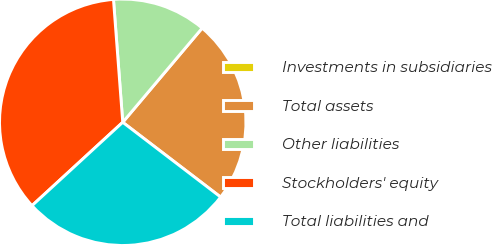<chart> <loc_0><loc_0><loc_500><loc_500><pie_chart><fcel>Investments in subsidiaries<fcel>Total assets<fcel>Other liabilities<fcel>Stockholders' equity<fcel>Total liabilities and<nl><fcel>0.0%<fcel>24.23%<fcel>12.35%<fcel>35.63%<fcel>27.79%<nl></chart> 